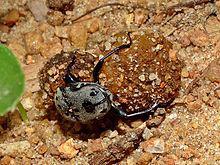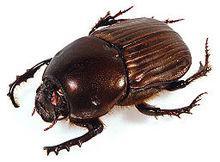The first image is the image on the left, the second image is the image on the right. Considering the images on both sides, is "There is a beetle that is not on a dung ball, in one image." valid? Answer yes or no. Yes. 